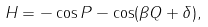<formula> <loc_0><loc_0><loc_500><loc_500>H = - \cos P - \cos ( \beta Q + \delta ) ,</formula> 